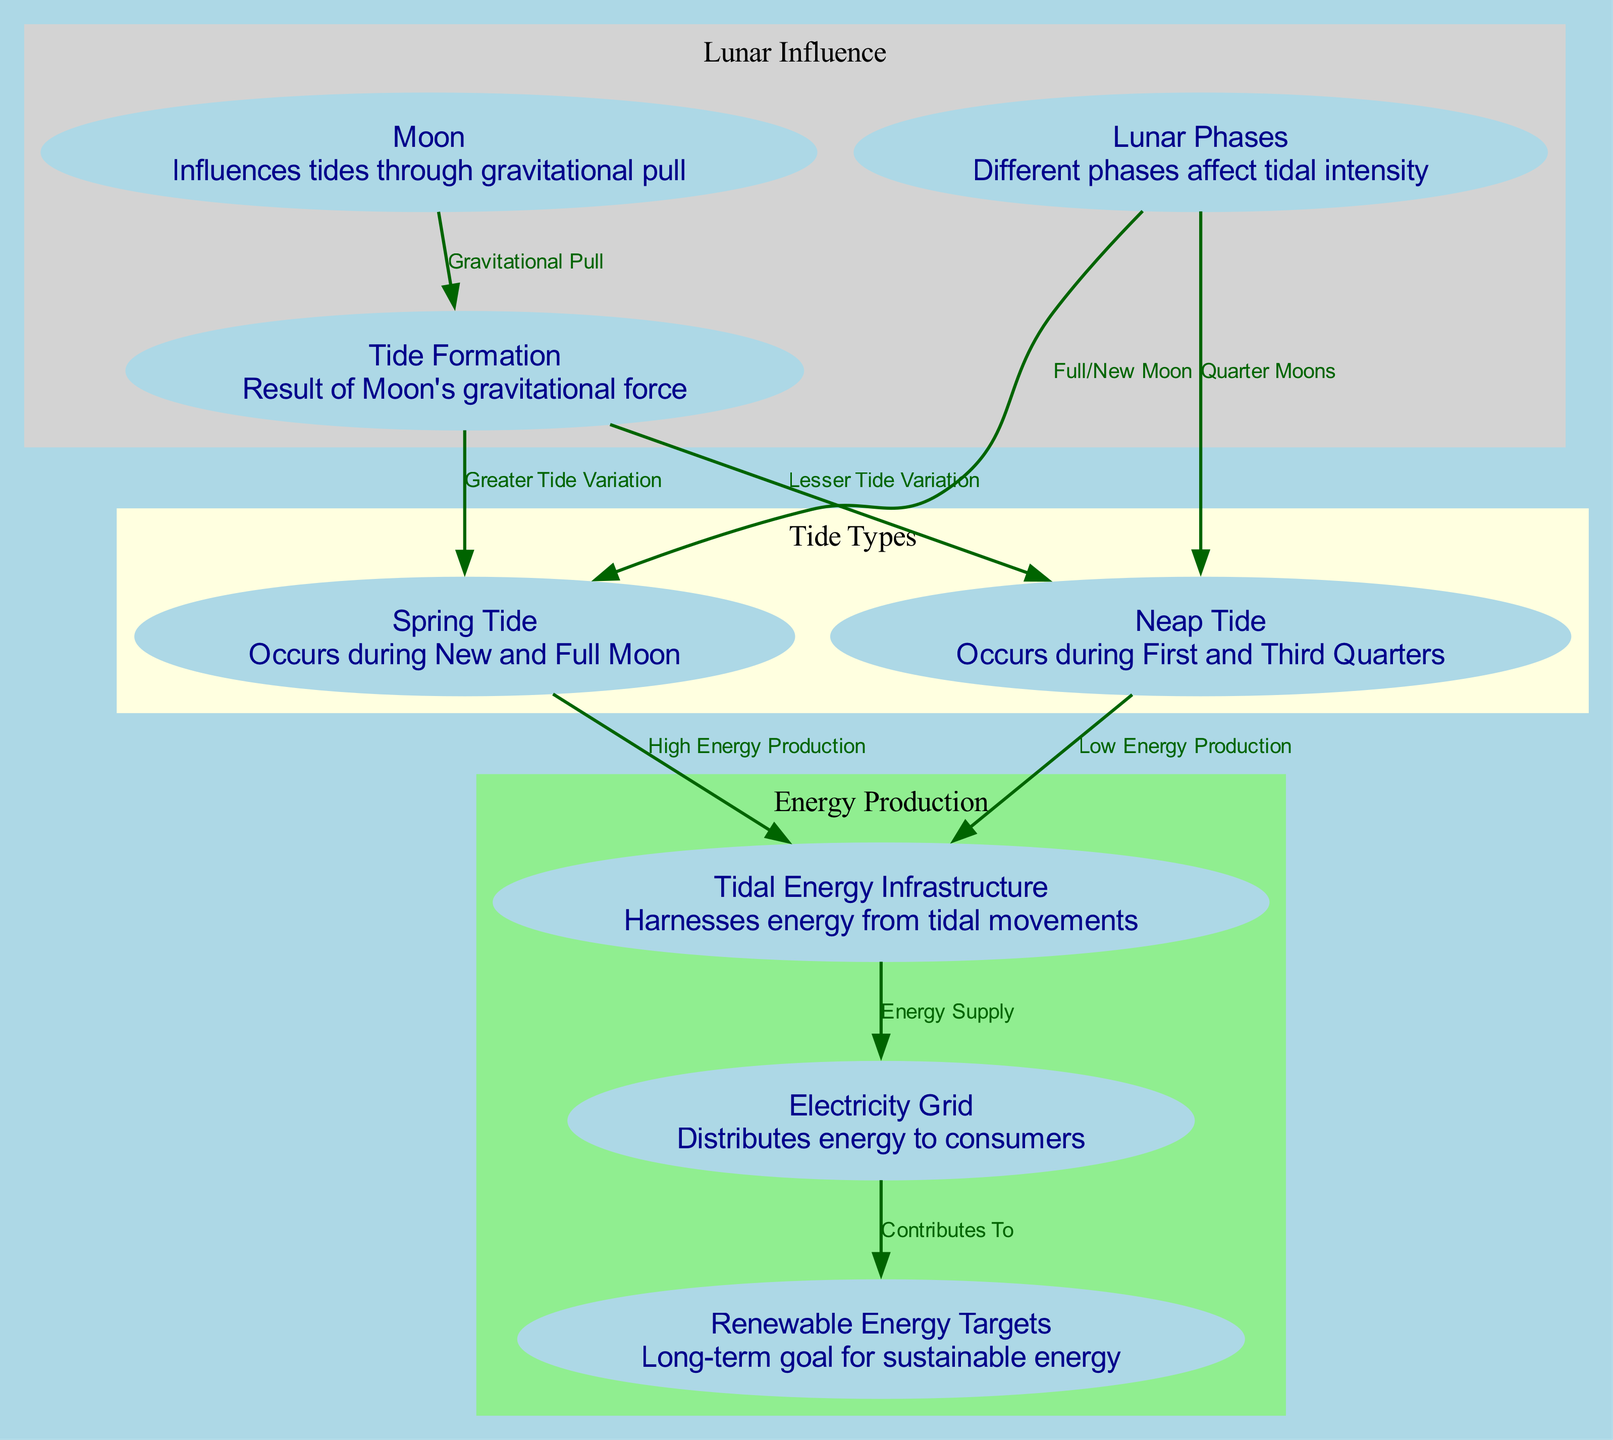What node describes the influence of the Moon? The node labeled "Moon" describes its gravitational influence on tides, which is explicitly mentioned as "Influences tides through gravitational pull."
Answer: Moon What type of tide occurs during the New and Full Moon? The relationship from the "lunar_phases" node directly to the "spring_tide" node indicates that it is a "Spring Tide" that occurs during New and Full Moons.
Answer: Spring Tide How many nodes are involved in the energy production section? The energy production section includes three nodes: "Tidal Energy Infrastructure," "Electricity Grid," and "Renewable Energy Targets," confirming a count of three nodes.
Answer: 3 What is the relationship between spring tides and tidal energy production? The edge from "spring_tide" to "tidal_energy_infrastructure" specifies that spring tides result in "High Energy Production," indicating a strong positive relationship.
Answer: High Energy Production What happens to energy production during neap tides? The edge from "neap_tide" to "tidal_energy_infrastructure" indicates that as a result of neap tides, there is "Low Energy Production," showing a decrease in energy output during this phase.
Answer: Low Energy Production Which lunar phases are related to higher tidal variations? The connection from the "lunar_phases" to the "spring_tide" node illustrates that both Full and New Moons lead to greater tidal variations compared to other phases.
Answer: Spring Tide How does tidal energy infrastructure contribute to renewable energy targets? The edge from "electricity_grid" to "renewable_energy_targets" shows that the electricity grid contributes to the renewable energy targets, signifying an integral part of the overall sustainable energy goal.
Answer: Contributes To During which lunar phases do neap tides occur? The connection from the "lunar_phases" to the "neap_tide" node indicates they occur during the First and Third Quarters of the Moon.
Answer: Quarter Moons 